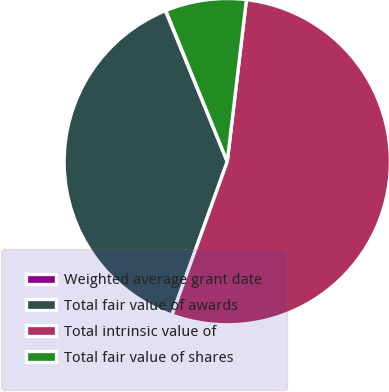<chart> <loc_0><loc_0><loc_500><loc_500><pie_chart><fcel>Weighted average grant date<fcel>Total fair value of awards<fcel>Total intrinsic value of<fcel>Total fair value of shares<nl><fcel>0.05%<fcel>38.3%<fcel>53.63%<fcel>8.02%<nl></chart> 